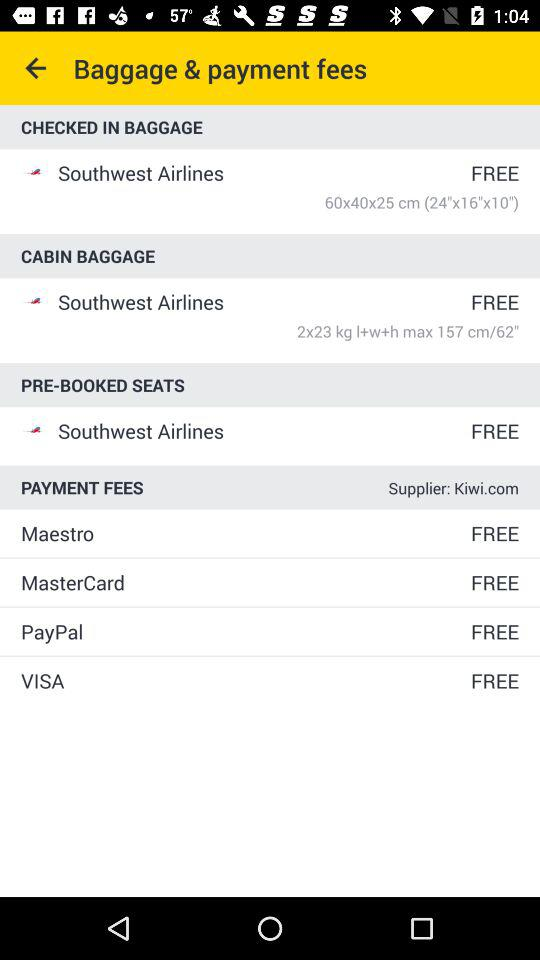Are pre-booked seats on "Southwest Airlines" free? Pre-booked seats on "Southwest Airlines" are free. 